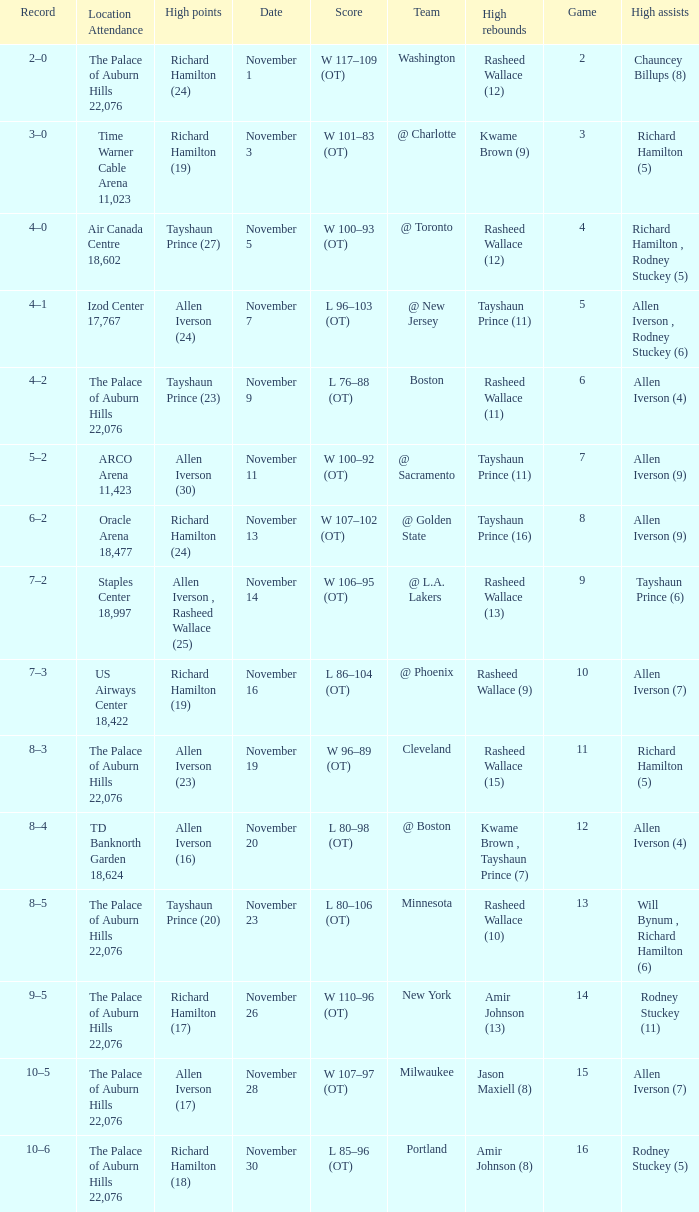What is the average Game, when Team is "Milwaukee"? 15.0. 